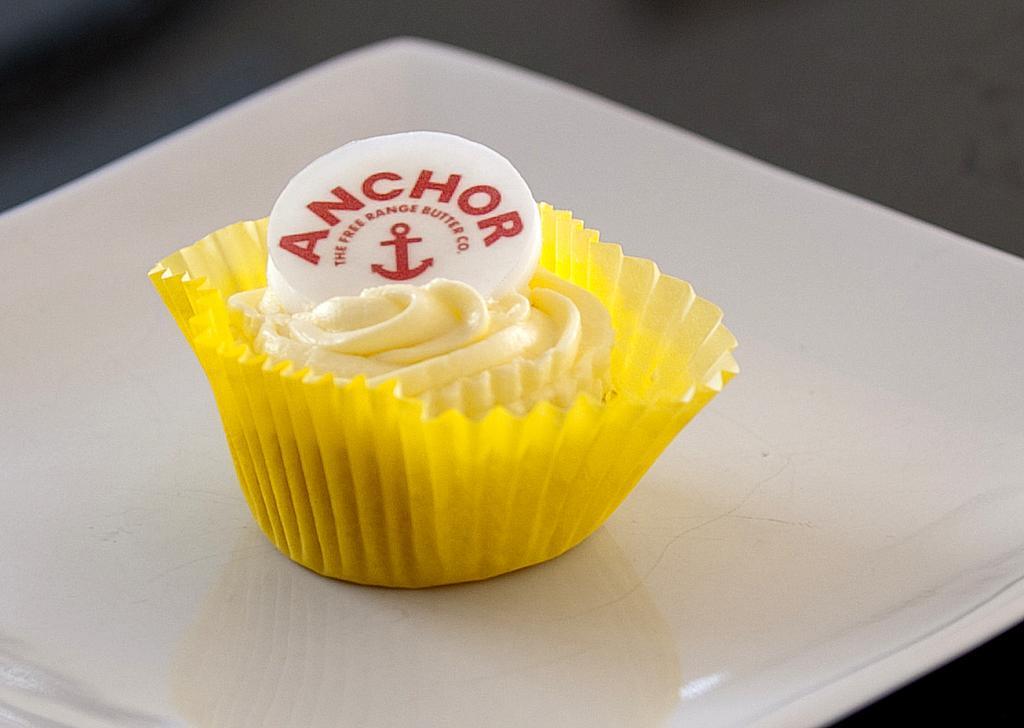Describe this image in one or two sentences. In this image there is a white plate on which there is a paper cup which contains butter in it. On the butter there is a logo. 